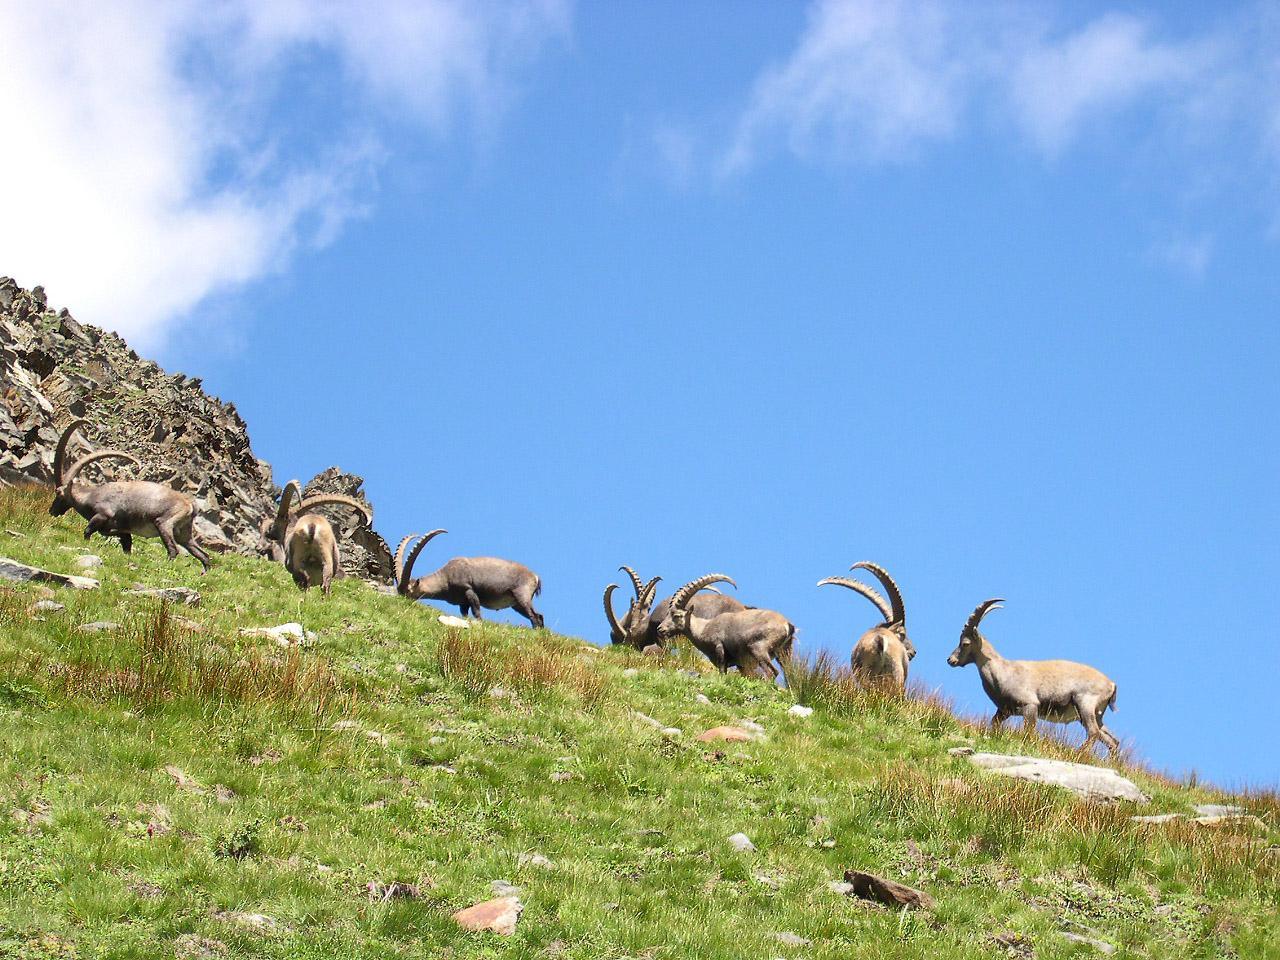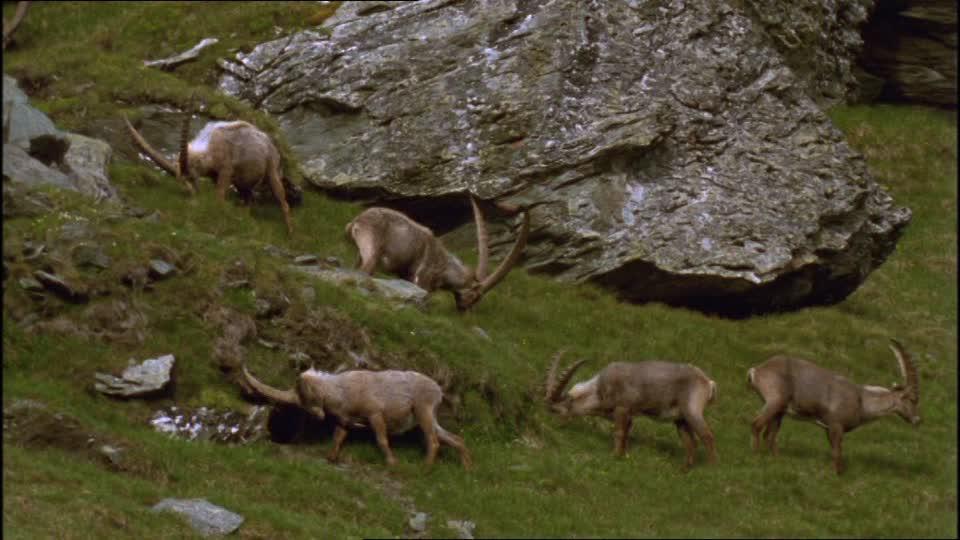The first image is the image on the left, the second image is the image on the right. Assess this claim about the two images: "At least one antelope is standing on a rocky grassless mountain.". Correct or not? Answer yes or no. No. The first image is the image on the left, the second image is the image on the right. For the images displayed, is the sentence "An area of sky blue is visible behind at least one mountain." factually correct? Answer yes or no. Yes. 